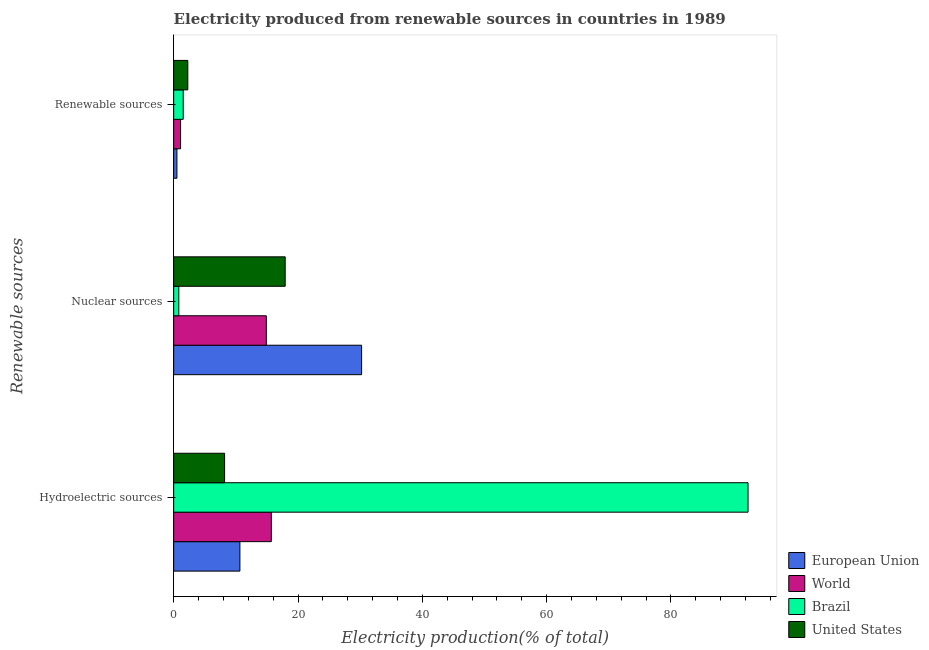How many different coloured bars are there?
Provide a succinct answer. 4. How many groups of bars are there?
Give a very brief answer. 3. Are the number of bars on each tick of the Y-axis equal?
Give a very brief answer. Yes. How many bars are there on the 3rd tick from the top?
Provide a short and direct response. 4. How many bars are there on the 1st tick from the bottom?
Your answer should be very brief. 4. What is the label of the 1st group of bars from the top?
Give a very brief answer. Renewable sources. What is the percentage of electricity produced by nuclear sources in World?
Offer a very short reply. 14.9. Across all countries, what is the maximum percentage of electricity produced by renewable sources?
Offer a terse response. 2.27. Across all countries, what is the minimum percentage of electricity produced by renewable sources?
Provide a short and direct response. 0.52. In which country was the percentage of electricity produced by renewable sources minimum?
Your response must be concise. European Union. What is the total percentage of electricity produced by hydroelectric sources in the graph?
Your answer should be very brief. 126.96. What is the difference between the percentage of electricity produced by hydroelectric sources in Brazil and that in United States?
Your answer should be compact. 84.21. What is the difference between the percentage of electricity produced by renewable sources in United States and the percentage of electricity produced by nuclear sources in Brazil?
Make the answer very short. 1.45. What is the average percentage of electricity produced by renewable sources per country?
Your answer should be compact. 1.36. What is the difference between the percentage of electricity produced by hydroelectric sources and percentage of electricity produced by nuclear sources in Brazil?
Your answer should be very brief. 91.58. What is the ratio of the percentage of electricity produced by hydroelectric sources in World to that in United States?
Provide a succinct answer. 1.92. Is the percentage of electricity produced by hydroelectric sources in United States less than that in Brazil?
Your answer should be compact. Yes. What is the difference between the highest and the second highest percentage of electricity produced by hydroelectric sources?
Ensure brevity in your answer.  76.69. What is the difference between the highest and the lowest percentage of electricity produced by renewable sources?
Ensure brevity in your answer.  1.75. In how many countries, is the percentage of electricity produced by hydroelectric sources greater than the average percentage of electricity produced by hydroelectric sources taken over all countries?
Offer a terse response. 1. Is it the case that in every country, the sum of the percentage of electricity produced by hydroelectric sources and percentage of electricity produced by nuclear sources is greater than the percentage of electricity produced by renewable sources?
Offer a terse response. Yes. How many countries are there in the graph?
Your response must be concise. 4. Are the values on the major ticks of X-axis written in scientific E-notation?
Give a very brief answer. No. Does the graph contain any zero values?
Provide a short and direct response. No. Where does the legend appear in the graph?
Ensure brevity in your answer.  Bottom right. What is the title of the graph?
Your answer should be compact. Electricity produced from renewable sources in countries in 1989. What is the label or title of the X-axis?
Your answer should be compact. Electricity production(% of total). What is the label or title of the Y-axis?
Provide a succinct answer. Renewable sources. What is the Electricity production(% of total) in European Union in Hydroelectric sources?
Ensure brevity in your answer.  10.66. What is the Electricity production(% of total) of World in Hydroelectric sources?
Your answer should be very brief. 15.71. What is the Electricity production(% of total) in Brazil in Hydroelectric sources?
Provide a succinct answer. 92.4. What is the Electricity production(% of total) of United States in Hydroelectric sources?
Provide a succinct answer. 8.19. What is the Electricity production(% of total) in European Union in Nuclear sources?
Make the answer very short. 30.23. What is the Electricity production(% of total) in World in Nuclear sources?
Keep it short and to the point. 14.9. What is the Electricity production(% of total) in Brazil in Nuclear sources?
Keep it short and to the point. 0.83. What is the Electricity production(% of total) of United States in Nuclear sources?
Provide a short and direct response. 17.94. What is the Electricity production(% of total) of European Union in Renewable sources?
Make the answer very short. 0.52. What is the Electricity production(% of total) in World in Renewable sources?
Your answer should be compact. 1.11. What is the Electricity production(% of total) of Brazil in Renewable sources?
Provide a succinct answer. 1.54. What is the Electricity production(% of total) in United States in Renewable sources?
Your response must be concise. 2.27. Across all Renewable sources, what is the maximum Electricity production(% of total) in European Union?
Your answer should be very brief. 30.23. Across all Renewable sources, what is the maximum Electricity production(% of total) in World?
Your answer should be very brief. 15.71. Across all Renewable sources, what is the maximum Electricity production(% of total) of Brazil?
Ensure brevity in your answer.  92.4. Across all Renewable sources, what is the maximum Electricity production(% of total) in United States?
Keep it short and to the point. 17.94. Across all Renewable sources, what is the minimum Electricity production(% of total) in European Union?
Provide a short and direct response. 0.52. Across all Renewable sources, what is the minimum Electricity production(% of total) in World?
Your response must be concise. 1.11. Across all Renewable sources, what is the minimum Electricity production(% of total) of Brazil?
Provide a short and direct response. 0.83. Across all Renewable sources, what is the minimum Electricity production(% of total) of United States?
Your answer should be very brief. 2.27. What is the total Electricity production(% of total) in European Union in the graph?
Give a very brief answer. 41.41. What is the total Electricity production(% of total) of World in the graph?
Your response must be concise. 31.72. What is the total Electricity production(% of total) in Brazil in the graph?
Give a very brief answer. 94.76. What is the total Electricity production(% of total) in United States in the graph?
Ensure brevity in your answer.  28.4. What is the difference between the Electricity production(% of total) of European Union in Hydroelectric sources and that in Nuclear sources?
Ensure brevity in your answer.  -19.58. What is the difference between the Electricity production(% of total) of World in Hydroelectric sources and that in Nuclear sources?
Provide a succinct answer. 0.81. What is the difference between the Electricity production(% of total) in Brazil in Hydroelectric sources and that in Nuclear sources?
Ensure brevity in your answer.  91.58. What is the difference between the Electricity production(% of total) of United States in Hydroelectric sources and that in Nuclear sources?
Ensure brevity in your answer.  -9.75. What is the difference between the Electricity production(% of total) in European Union in Hydroelectric sources and that in Renewable sources?
Provide a short and direct response. 10.13. What is the difference between the Electricity production(% of total) in World in Hydroelectric sources and that in Renewable sources?
Give a very brief answer. 14.6. What is the difference between the Electricity production(% of total) of Brazil in Hydroelectric sources and that in Renewable sources?
Offer a terse response. 90.87. What is the difference between the Electricity production(% of total) of United States in Hydroelectric sources and that in Renewable sources?
Provide a succinct answer. 5.92. What is the difference between the Electricity production(% of total) in European Union in Nuclear sources and that in Renewable sources?
Your answer should be very brief. 29.71. What is the difference between the Electricity production(% of total) of World in Nuclear sources and that in Renewable sources?
Your answer should be compact. 13.79. What is the difference between the Electricity production(% of total) of Brazil in Nuclear sources and that in Renewable sources?
Keep it short and to the point. -0.71. What is the difference between the Electricity production(% of total) of United States in Nuclear sources and that in Renewable sources?
Ensure brevity in your answer.  15.67. What is the difference between the Electricity production(% of total) in European Union in Hydroelectric sources and the Electricity production(% of total) in World in Nuclear sources?
Make the answer very short. -4.25. What is the difference between the Electricity production(% of total) in European Union in Hydroelectric sources and the Electricity production(% of total) in Brazil in Nuclear sources?
Offer a terse response. 9.83. What is the difference between the Electricity production(% of total) in European Union in Hydroelectric sources and the Electricity production(% of total) in United States in Nuclear sources?
Your answer should be compact. -7.28. What is the difference between the Electricity production(% of total) in World in Hydroelectric sources and the Electricity production(% of total) in Brazil in Nuclear sources?
Provide a short and direct response. 14.88. What is the difference between the Electricity production(% of total) of World in Hydroelectric sources and the Electricity production(% of total) of United States in Nuclear sources?
Keep it short and to the point. -2.23. What is the difference between the Electricity production(% of total) of Brazil in Hydroelectric sources and the Electricity production(% of total) of United States in Nuclear sources?
Your answer should be very brief. 74.46. What is the difference between the Electricity production(% of total) in European Union in Hydroelectric sources and the Electricity production(% of total) in World in Renewable sources?
Provide a short and direct response. 9.55. What is the difference between the Electricity production(% of total) in European Union in Hydroelectric sources and the Electricity production(% of total) in Brazil in Renewable sources?
Give a very brief answer. 9.12. What is the difference between the Electricity production(% of total) in European Union in Hydroelectric sources and the Electricity production(% of total) in United States in Renewable sources?
Your response must be concise. 8.38. What is the difference between the Electricity production(% of total) in World in Hydroelectric sources and the Electricity production(% of total) in Brazil in Renewable sources?
Give a very brief answer. 14.17. What is the difference between the Electricity production(% of total) in World in Hydroelectric sources and the Electricity production(% of total) in United States in Renewable sources?
Provide a short and direct response. 13.44. What is the difference between the Electricity production(% of total) in Brazil in Hydroelectric sources and the Electricity production(% of total) in United States in Renewable sources?
Your answer should be very brief. 90.13. What is the difference between the Electricity production(% of total) of European Union in Nuclear sources and the Electricity production(% of total) of World in Renewable sources?
Your response must be concise. 29.12. What is the difference between the Electricity production(% of total) in European Union in Nuclear sources and the Electricity production(% of total) in Brazil in Renewable sources?
Give a very brief answer. 28.69. What is the difference between the Electricity production(% of total) in European Union in Nuclear sources and the Electricity production(% of total) in United States in Renewable sources?
Provide a succinct answer. 27.96. What is the difference between the Electricity production(% of total) in World in Nuclear sources and the Electricity production(% of total) in Brazil in Renewable sources?
Make the answer very short. 13.37. What is the difference between the Electricity production(% of total) of World in Nuclear sources and the Electricity production(% of total) of United States in Renewable sources?
Make the answer very short. 12.63. What is the difference between the Electricity production(% of total) in Brazil in Nuclear sources and the Electricity production(% of total) in United States in Renewable sources?
Make the answer very short. -1.45. What is the average Electricity production(% of total) in European Union per Renewable sources?
Give a very brief answer. 13.8. What is the average Electricity production(% of total) of World per Renewable sources?
Keep it short and to the point. 10.57. What is the average Electricity production(% of total) in Brazil per Renewable sources?
Provide a short and direct response. 31.59. What is the average Electricity production(% of total) in United States per Renewable sources?
Your answer should be compact. 9.47. What is the difference between the Electricity production(% of total) in European Union and Electricity production(% of total) in World in Hydroelectric sources?
Offer a very short reply. -5.05. What is the difference between the Electricity production(% of total) of European Union and Electricity production(% of total) of Brazil in Hydroelectric sources?
Your answer should be very brief. -81.75. What is the difference between the Electricity production(% of total) of European Union and Electricity production(% of total) of United States in Hydroelectric sources?
Your response must be concise. 2.47. What is the difference between the Electricity production(% of total) in World and Electricity production(% of total) in Brazil in Hydroelectric sources?
Give a very brief answer. -76.69. What is the difference between the Electricity production(% of total) of World and Electricity production(% of total) of United States in Hydroelectric sources?
Provide a short and direct response. 7.52. What is the difference between the Electricity production(% of total) of Brazil and Electricity production(% of total) of United States in Hydroelectric sources?
Your answer should be very brief. 84.21. What is the difference between the Electricity production(% of total) of European Union and Electricity production(% of total) of World in Nuclear sources?
Provide a succinct answer. 15.33. What is the difference between the Electricity production(% of total) of European Union and Electricity production(% of total) of Brazil in Nuclear sources?
Ensure brevity in your answer.  29.41. What is the difference between the Electricity production(% of total) in European Union and Electricity production(% of total) in United States in Nuclear sources?
Make the answer very short. 12.29. What is the difference between the Electricity production(% of total) in World and Electricity production(% of total) in Brazil in Nuclear sources?
Your answer should be compact. 14.08. What is the difference between the Electricity production(% of total) of World and Electricity production(% of total) of United States in Nuclear sources?
Offer a very short reply. -3.04. What is the difference between the Electricity production(% of total) in Brazil and Electricity production(% of total) in United States in Nuclear sources?
Your answer should be compact. -17.11. What is the difference between the Electricity production(% of total) in European Union and Electricity production(% of total) in World in Renewable sources?
Give a very brief answer. -0.59. What is the difference between the Electricity production(% of total) of European Union and Electricity production(% of total) of Brazil in Renewable sources?
Your answer should be compact. -1.01. What is the difference between the Electricity production(% of total) of European Union and Electricity production(% of total) of United States in Renewable sources?
Your answer should be compact. -1.75. What is the difference between the Electricity production(% of total) in World and Electricity production(% of total) in Brazil in Renewable sources?
Provide a short and direct response. -0.43. What is the difference between the Electricity production(% of total) of World and Electricity production(% of total) of United States in Renewable sources?
Provide a succinct answer. -1.16. What is the difference between the Electricity production(% of total) in Brazil and Electricity production(% of total) in United States in Renewable sources?
Make the answer very short. -0.74. What is the ratio of the Electricity production(% of total) in European Union in Hydroelectric sources to that in Nuclear sources?
Your response must be concise. 0.35. What is the ratio of the Electricity production(% of total) in World in Hydroelectric sources to that in Nuclear sources?
Offer a terse response. 1.05. What is the ratio of the Electricity production(% of total) of Brazil in Hydroelectric sources to that in Nuclear sources?
Offer a very short reply. 111.85. What is the ratio of the Electricity production(% of total) in United States in Hydroelectric sources to that in Nuclear sources?
Provide a short and direct response. 0.46. What is the ratio of the Electricity production(% of total) of European Union in Hydroelectric sources to that in Renewable sources?
Your response must be concise. 20.41. What is the ratio of the Electricity production(% of total) in World in Hydroelectric sources to that in Renewable sources?
Your response must be concise. 14.16. What is the ratio of the Electricity production(% of total) in Brazil in Hydroelectric sources to that in Renewable sources?
Keep it short and to the point. 60.15. What is the ratio of the Electricity production(% of total) in United States in Hydroelectric sources to that in Renewable sources?
Your answer should be very brief. 3.6. What is the ratio of the Electricity production(% of total) of European Union in Nuclear sources to that in Renewable sources?
Provide a short and direct response. 57.92. What is the ratio of the Electricity production(% of total) of World in Nuclear sources to that in Renewable sources?
Keep it short and to the point. 13.43. What is the ratio of the Electricity production(% of total) in Brazil in Nuclear sources to that in Renewable sources?
Your answer should be compact. 0.54. What is the ratio of the Electricity production(% of total) in United States in Nuclear sources to that in Renewable sources?
Provide a short and direct response. 7.89. What is the difference between the highest and the second highest Electricity production(% of total) in European Union?
Provide a succinct answer. 19.58. What is the difference between the highest and the second highest Electricity production(% of total) of World?
Make the answer very short. 0.81. What is the difference between the highest and the second highest Electricity production(% of total) of Brazil?
Make the answer very short. 90.87. What is the difference between the highest and the second highest Electricity production(% of total) in United States?
Your answer should be compact. 9.75. What is the difference between the highest and the lowest Electricity production(% of total) in European Union?
Give a very brief answer. 29.71. What is the difference between the highest and the lowest Electricity production(% of total) of World?
Provide a short and direct response. 14.6. What is the difference between the highest and the lowest Electricity production(% of total) of Brazil?
Your response must be concise. 91.58. What is the difference between the highest and the lowest Electricity production(% of total) of United States?
Your answer should be compact. 15.67. 